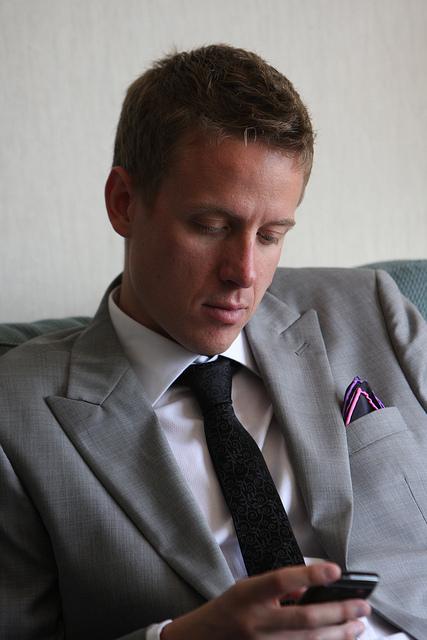What is the man holding?
Answer briefly. Cell phone. Is this man wearing a dress shirt?
Keep it brief. Yes. Does he have a pink handkerchief?
Short answer required. Yes. 